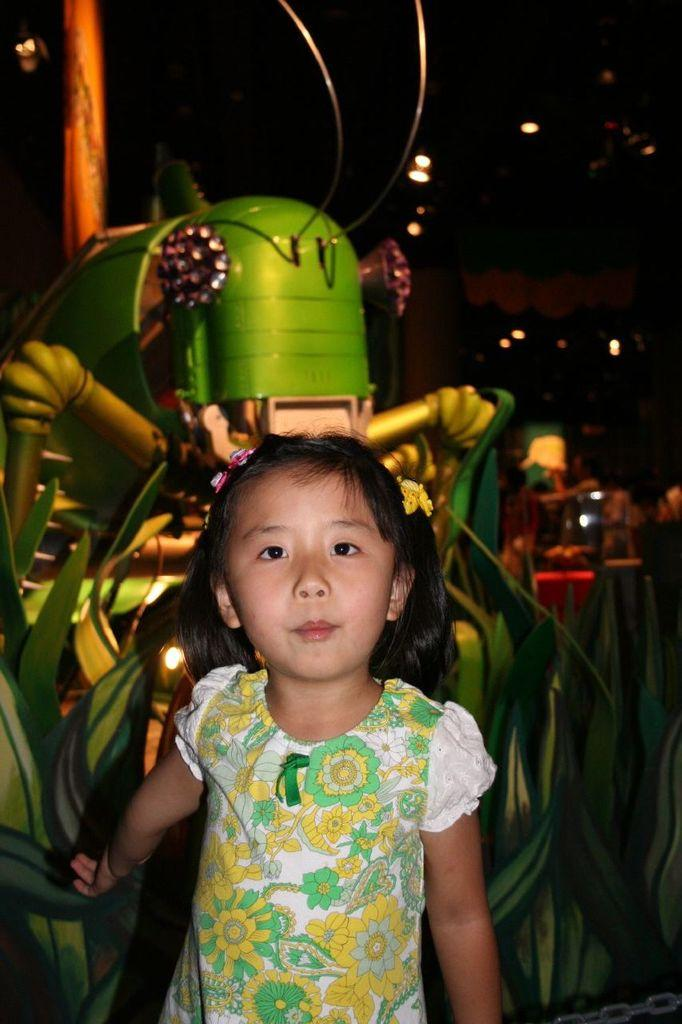Who is the main subject in the image? There is a small girl in the image. What is the girl doing in the picture? The girl is standing and posing for the picture. Where is the girl positioned in the image? The girl is in the center of the image. What can be seen behind the girl in the image? There is a spider-like object behind the girl. How would you describe the overall lighting in the image? The background of the image is dark. What type of ice can be seen melting on the girl's head in the image? There is no ice present in the image, so it cannot be melting on the girl's head. 